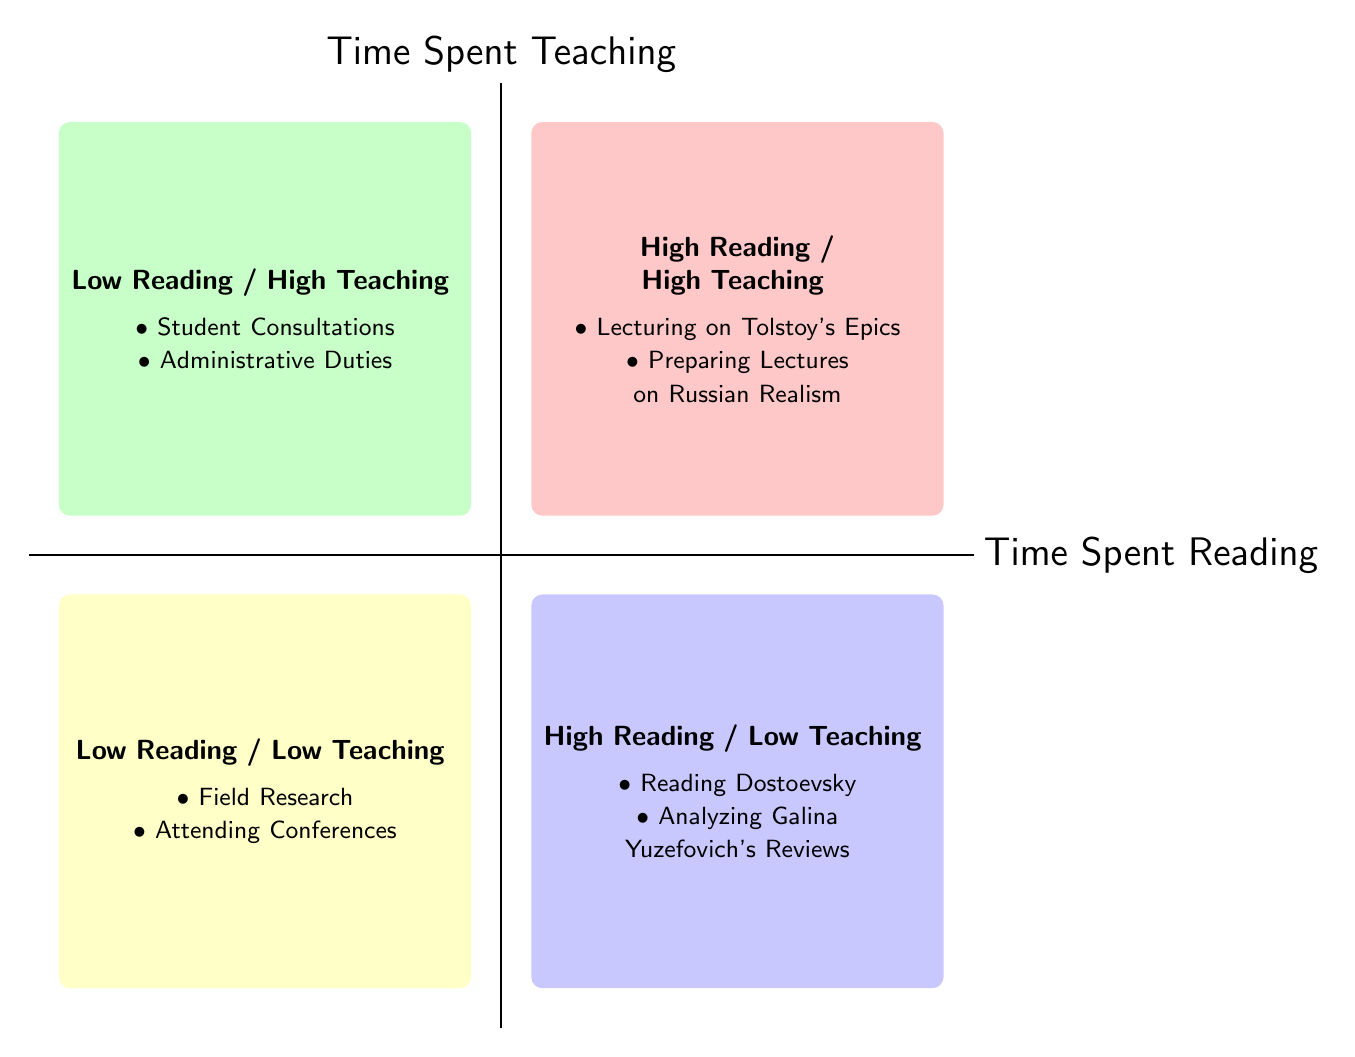What activities fall under High Reading / Low Teaching? In the High Reading / Low Teaching quadrant, we look at the activities listed there. They include "Reading Dostoevsky" and "Analyzing Galina Yuzefovich's Reviews".
Answer: Reading Dostoevsky, Analyzing Galina Yuzefovich's Reviews Which quadrant has activities related to administrative duties? The activities related to administrative duties are found in the Low Reading / High Teaching quadrant, which includes "Student Consultations" and "Administrative Duties".
Answer: Low Reading / High Teaching How many activities are there in the High Reading / High Teaching quadrant? We count the activities listed in the High Reading / High Teaching quadrant, which are "Lecturing on Tolstoy's Epics" and "Preparing Lectures on Russian Realism". There are two activities.
Answer: 2 What is the description of the activity in the High Reading / High Teaching quadrant? To find the description, we need to look at the activities in the High Reading / High Teaching quadrant. Both activities are related to teaching Tolstoy and preparing lecture materials.
Answer: In-depth lectures and discussions on 'War and Peace', Integrating current reading insights into lecture preparation What are the two main activities in the Low Reading / Low Teaching quadrant? In the Low Reading / Low Teaching quadrant, the activities listed are "Field Research" and "Attending Conferences".
Answer: Field Research, Attending Conferences Which quadrant has the least time spent on reading and teaching? The quadrant with the least time spent on both reading and teaching is Low Reading / Low Teaching, characterized by fewer activities relating to both aspects.
Answer: Low Reading / Low Teaching What is the focus of the activity "Student Consultations"? The description for "Student Consultations" is about advising students regarding their research projects, which reflects a focus on supporting students.
Answer: Focused on advising students about their research projects Which quadrant would you associate with a focus on complex literature? High Reading / Low Teaching is associated with complex literature, particularly shown through activities involving Dostoevsky and Yuzefovich.
Answer: High Reading / Low Teaching 